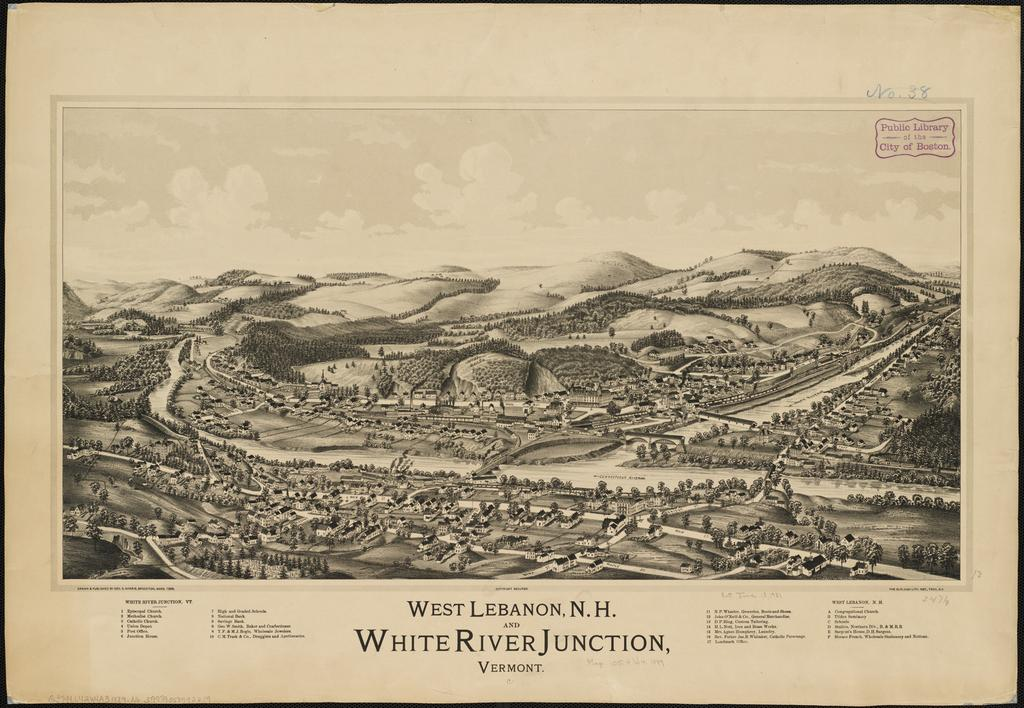<image>
Share a concise interpretation of the image provided. An art print showing West Lebanon N.H. and White River Junction Vermont. 